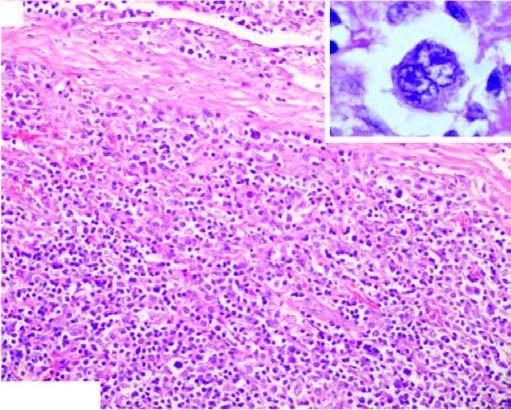s line of demarcation between gangrenous segment and the viable bowel bands of collagen forming nodules and characteristic lacunar rs cells?
Answer the question using a single word or phrase. No 